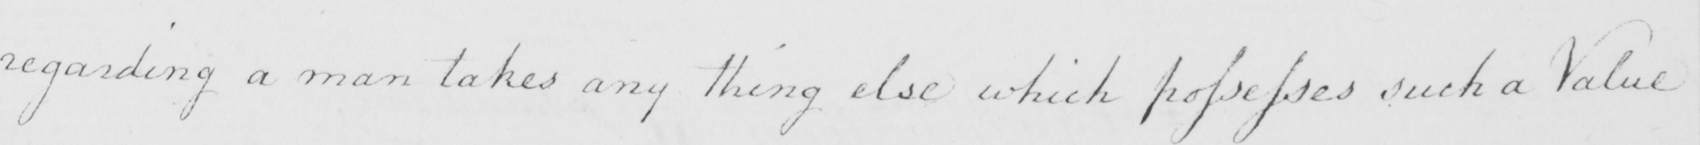What text is written in this handwritten line? regarding a man takes any thing else which possesses such a Value 